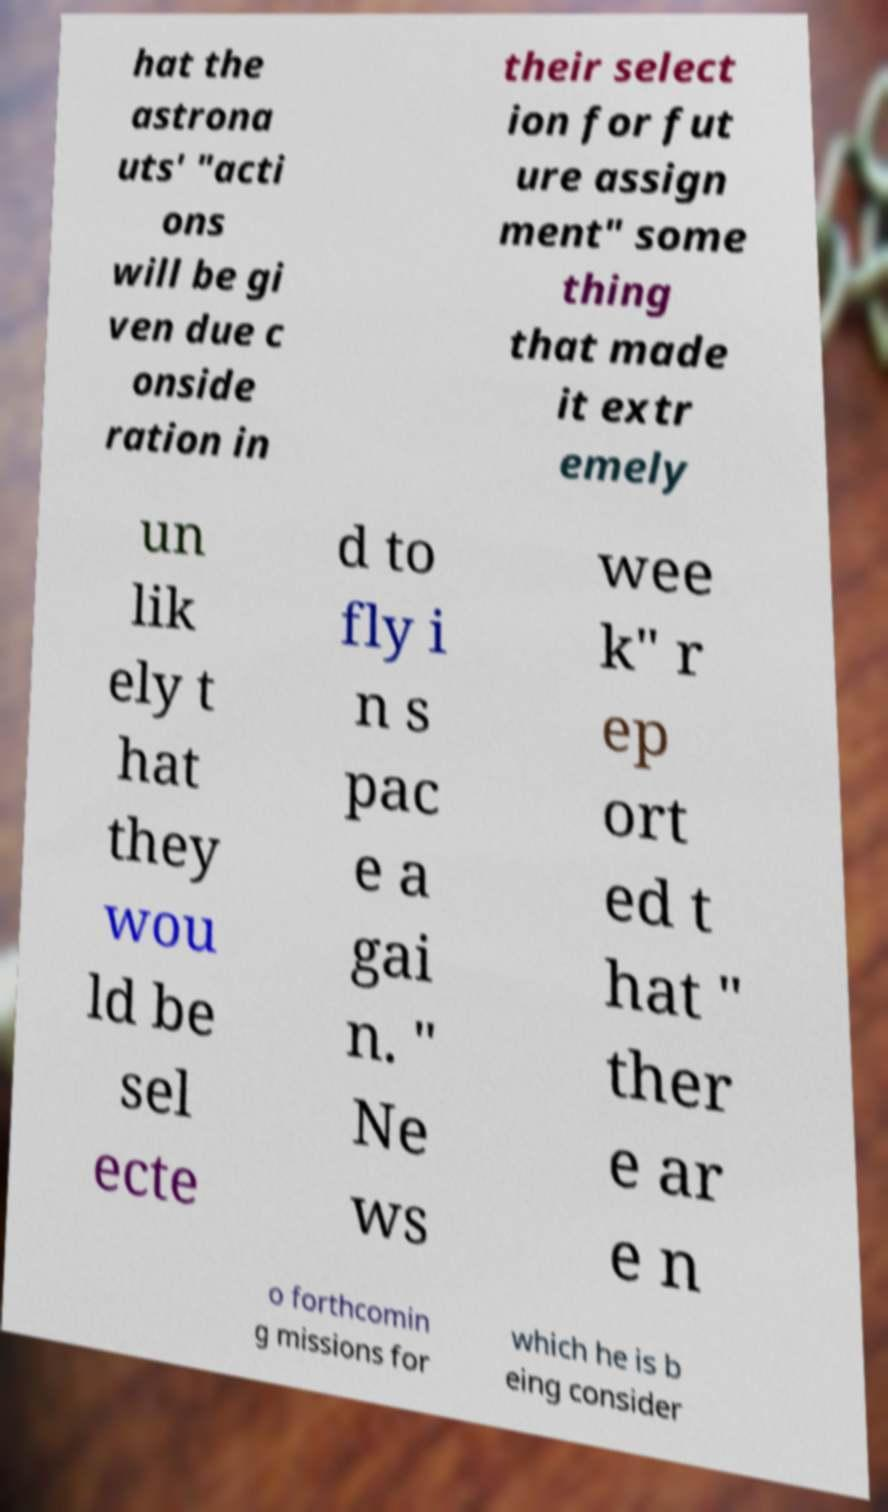Could you extract and type out the text from this image? hat the astrona uts' "acti ons will be gi ven due c onside ration in their select ion for fut ure assign ment" some thing that made it extr emely un lik ely t hat they wou ld be sel ecte d to fly i n s pac e a gai n. " Ne ws wee k" r ep ort ed t hat " ther e ar e n o forthcomin g missions for which he is b eing consider 